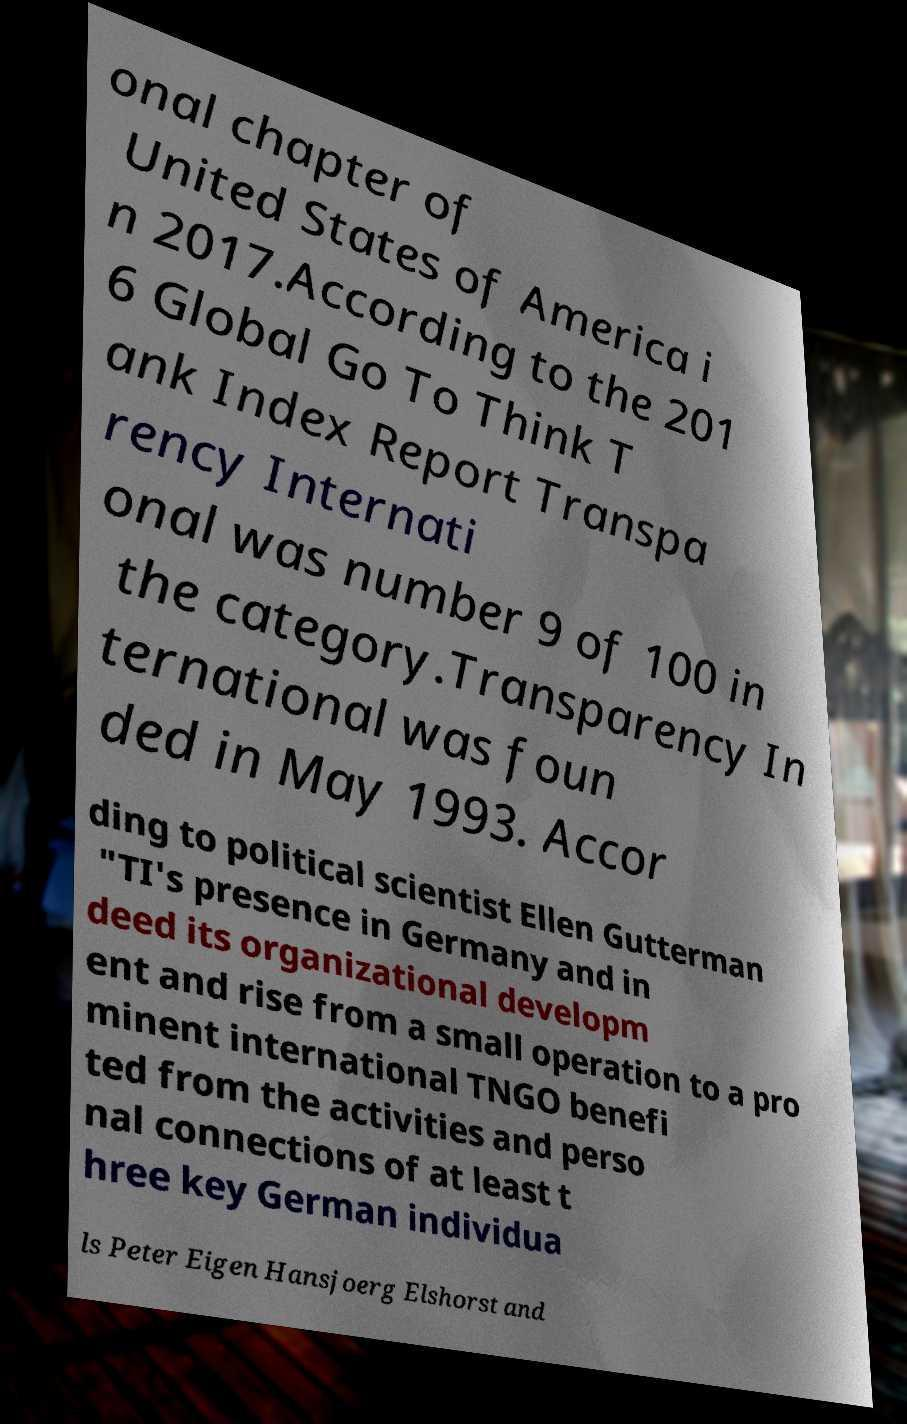Could you assist in decoding the text presented in this image and type it out clearly? onal chapter of United States of America i n 2017.According to the 201 6 Global Go To Think T ank Index Report Transpa rency Internati onal was number 9 of 100 in the category.Transparency In ternational was foun ded in May 1993. Accor ding to political scientist Ellen Gutterman "TI's presence in Germany and in deed its organizational developm ent and rise from a small operation to a pro minent international TNGO benefi ted from the activities and perso nal connections of at least t hree key German individua ls Peter Eigen Hansjoerg Elshorst and 